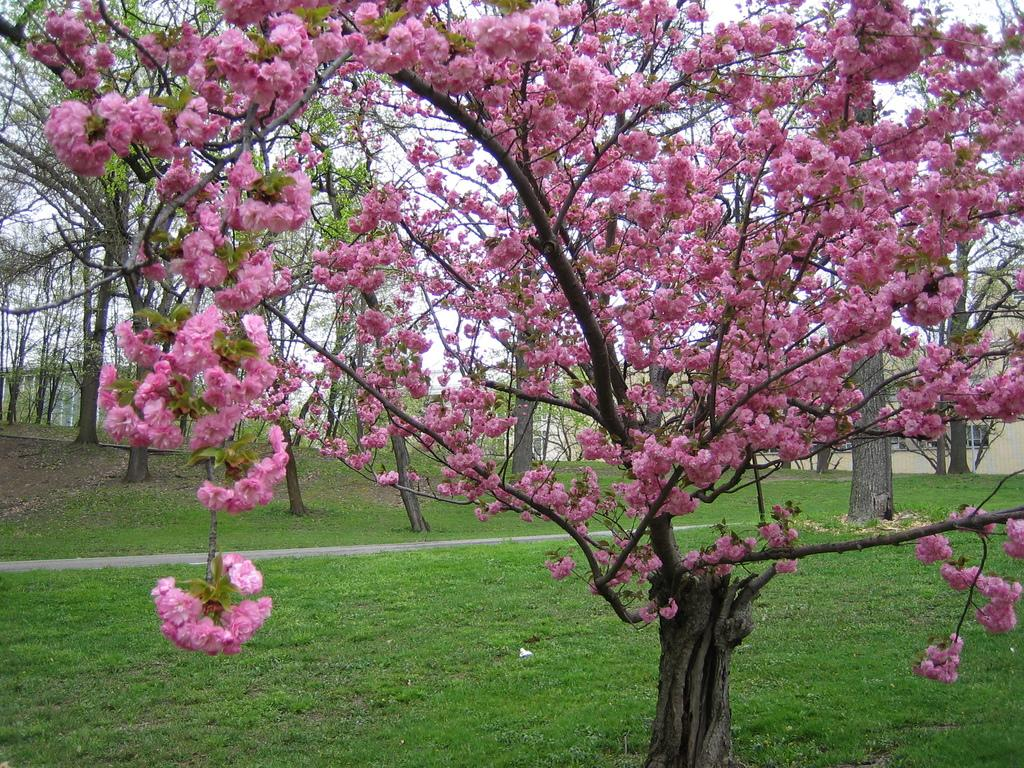What is located in the foreground of the image? There is a tree in the foreground of the image. What is the tree standing on? The tree is on the grass. What can be seen in the background of the image? There are trees and buildings in the background of the image. What part of the natural environment is visible in the image? The sky is visible in the background of the image. What type of collar can be seen on the tree in the image? There is no collar present on the tree in the image. Is there a basketball court visible in the image? There is no basketball court present in the image. 